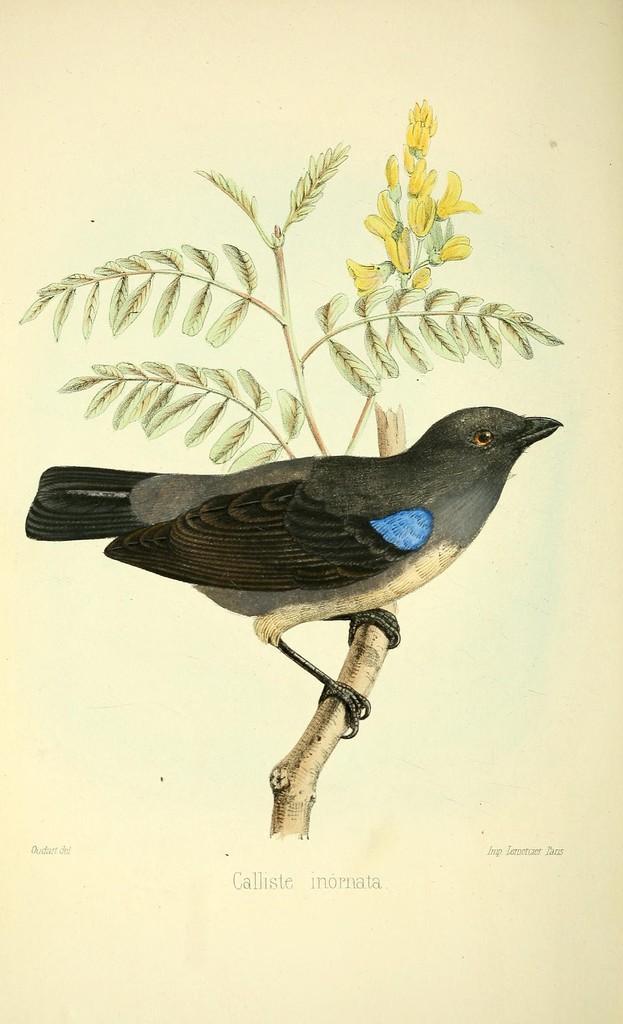How would you summarize this image in a sentence or two? This is a paper. On that there is a branch with leaves and yellow flowers. Also there is a black bird is sitting on the branch. Also something is written on the paper. 